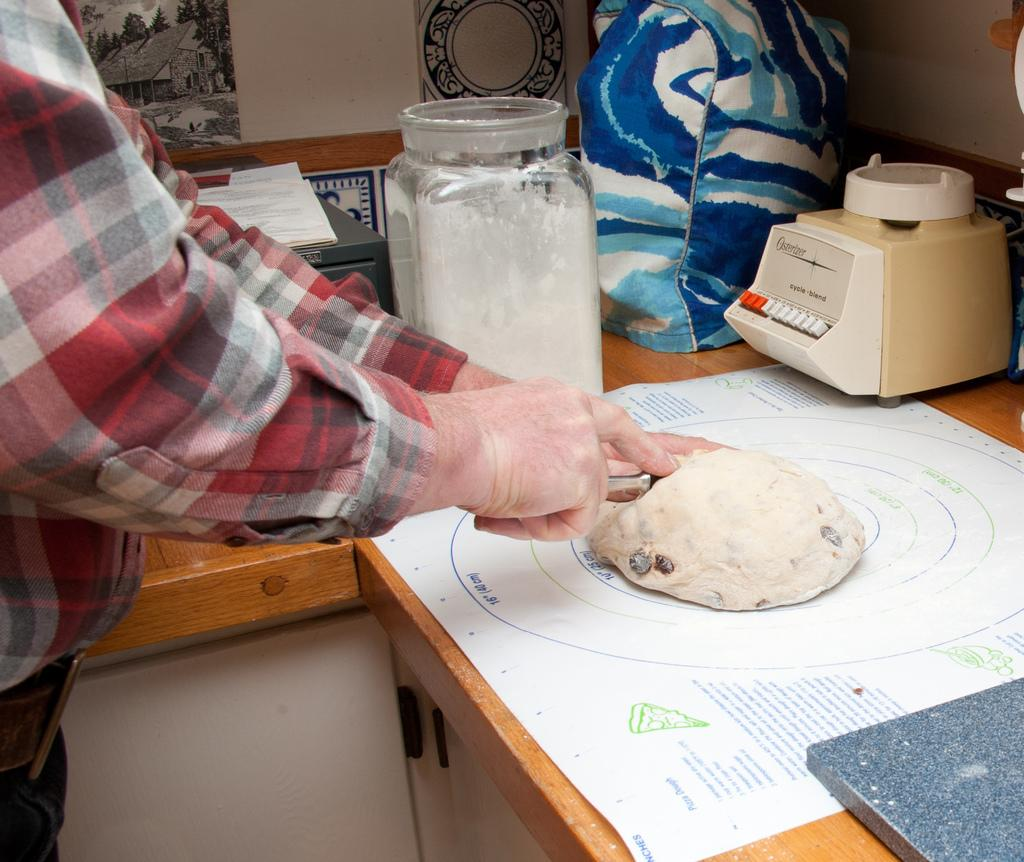What is the person holding in the image? There is a person holding something in the image, but the specific object cannot be determined from the provided facts. What type of equipment is present in the image? There is a machine in the image. What type of container is visible in the image? There is a glass jar in the image. What is on the table in the image? There are objects on the table in the image, but their specific nature cannot be determined from the provided facts. What can be seen in the background of the image? There is a wall visible in the background of the image. What type of tin is being used to create art in the image? There is no tin or art present in the image; it features a person holding something, a machine, a glass jar, objects on a table, and a wall in the background. 